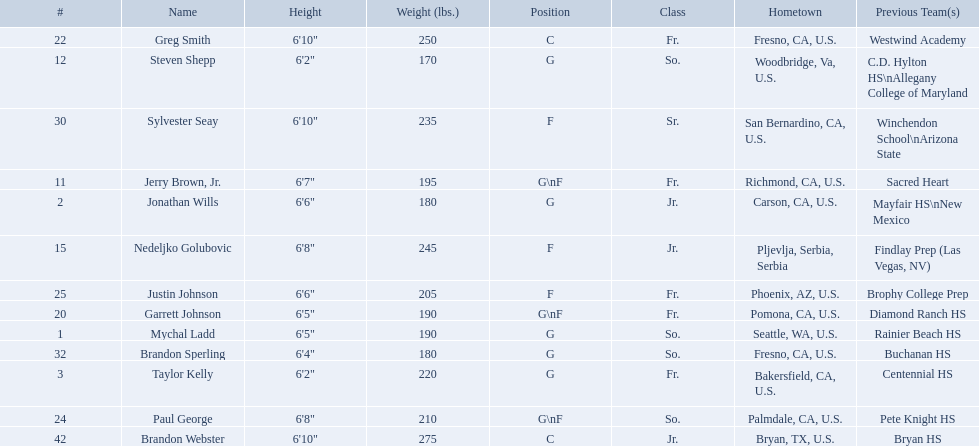What are the names of the basketball team players? Mychal Ladd, Jonathan Wills, Taylor Kelly, Jerry Brown, Jr., Steven Shepp, Nedeljko Golubovic, Garrett Johnson, Greg Smith, Paul George, Justin Johnson, Sylvester Seay, Brandon Sperling, Brandon Webster. Of these identify paul george and greg smith Greg Smith, Paul George. What are their corresponding heights? 6'10", 6'8". To who does the larger height correspond to? Greg Smith. What are the listed classes of the players? So., Jr., Fr., Fr., So., Jr., Fr., Fr., So., Fr., Sr., So., Jr. Which of these is not from the us? Jr. Write the full table. {'header': ['#', 'Name', 'Height', 'Weight (lbs.)', 'Position', 'Class', 'Hometown', 'Previous Team(s)'], 'rows': [['22', 'Greg Smith', '6\'10"', '250', 'C', 'Fr.', 'Fresno, CA, U.S.', 'Westwind Academy'], ['12', 'Steven Shepp', '6\'2"', '170', 'G', 'So.', 'Woodbridge, Va, U.S.', 'C.D. Hylton HS\\nAllegany College of Maryland'], ['30', 'Sylvester Seay', '6\'10"', '235', 'F', 'Sr.', 'San Bernardino, CA, U.S.', 'Winchendon School\\nArizona State'], ['11', 'Jerry Brown, Jr.', '6\'7"', '195', 'G\\nF', 'Fr.', 'Richmond, CA, U.S.', 'Sacred Heart'], ['2', 'Jonathan Wills', '6\'6"', '180', 'G', 'Jr.', 'Carson, CA, U.S.', 'Mayfair HS\\nNew Mexico'], ['15', 'Nedeljko Golubovic', '6\'8"', '245', 'F', 'Jr.', 'Pljevlja, Serbia, Serbia', 'Findlay Prep (Las Vegas, NV)'], ['25', 'Justin Johnson', '6\'6"', '205', 'F', 'Fr.', 'Phoenix, AZ, U.S.', 'Brophy College Prep'], ['20', 'Garrett Johnson', '6\'5"', '190', 'G\\nF', 'Fr.', 'Pomona, CA, U.S.', 'Diamond Ranch HS'], ['1', 'Mychal Ladd', '6\'5"', '190', 'G', 'So.', 'Seattle, WA, U.S.', 'Rainier Beach HS'], ['32', 'Brandon Sperling', '6\'4"', '180', 'G', 'So.', 'Fresno, CA, U.S.', 'Buchanan HS'], ['3', 'Taylor Kelly', '6\'2"', '220', 'G', 'Fr.', 'Bakersfield, CA, U.S.', 'Centennial HS'], ['24', 'Paul George', '6\'8"', '210', 'G\\nF', 'So.', 'Palmdale, CA, U.S.', 'Pete Knight HS'], ['42', 'Brandon Webster', '6\'10"', '275', 'C', 'Jr.', 'Bryan, TX, U.S.', 'Bryan HS']]} To which name does that entry correspond to? Nedeljko Golubovic. 